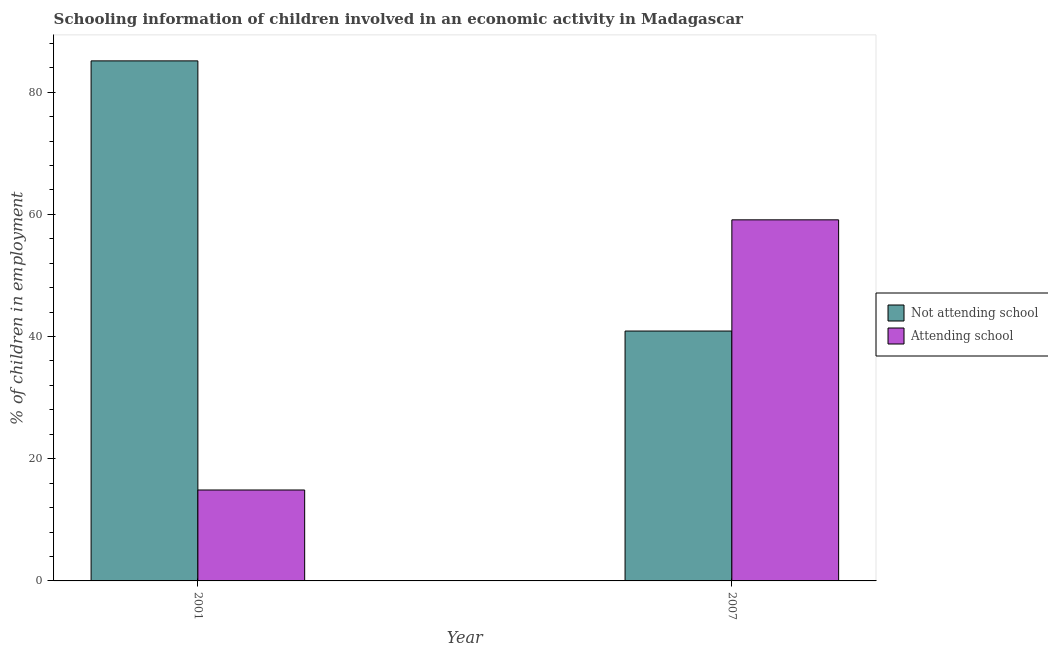How many different coloured bars are there?
Give a very brief answer. 2. How many groups of bars are there?
Your answer should be very brief. 2. Are the number of bars per tick equal to the number of legend labels?
Make the answer very short. Yes. Are the number of bars on each tick of the X-axis equal?
Provide a succinct answer. Yes. How many bars are there on the 2nd tick from the right?
Offer a very short reply. 2. What is the label of the 1st group of bars from the left?
Your answer should be very brief. 2001. What is the percentage of employed children who are not attending school in 2001?
Your response must be concise. 85.12. Across all years, what is the maximum percentage of employed children who are not attending school?
Ensure brevity in your answer.  85.12. Across all years, what is the minimum percentage of employed children who are not attending school?
Ensure brevity in your answer.  40.9. In which year was the percentage of employed children who are not attending school maximum?
Make the answer very short. 2001. In which year was the percentage of employed children who are attending school minimum?
Keep it short and to the point. 2001. What is the total percentage of employed children who are not attending school in the graph?
Ensure brevity in your answer.  126.02. What is the difference between the percentage of employed children who are not attending school in 2001 and that in 2007?
Provide a short and direct response. 44.22. What is the difference between the percentage of employed children who are attending school in 2001 and the percentage of employed children who are not attending school in 2007?
Ensure brevity in your answer.  -44.22. What is the average percentage of employed children who are attending school per year?
Give a very brief answer. 36.99. What is the ratio of the percentage of employed children who are attending school in 2001 to that in 2007?
Your response must be concise. 0.25. In how many years, is the percentage of employed children who are not attending school greater than the average percentage of employed children who are not attending school taken over all years?
Offer a very short reply. 1. What does the 2nd bar from the left in 2001 represents?
Provide a succinct answer. Attending school. What does the 1st bar from the right in 2001 represents?
Make the answer very short. Attending school. How many bars are there?
Make the answer very short. 4. Are the values on the major ticks of Y-axis written in scientific E-notation?
Your response must be concise. No. Does the graph contain grids?
Your answer should be compact. No. How many legend labels are there?
Your response must be concise. 2. What is the title of the graph?
Provide a succinct answer. Schooling information of children involved in an economic activity in Madagascar. What is the label or title of the Y-axis?
Your answer should be compact. % of children in employment. What is the % of children in employment in Not attending school in 2001?
Keep it short and to the point. 85.12. What is the % of children in employment in Attending school in 2001?
Provide a short and direct response. 14.88. What is the % of children in employment of Not attending school in 2007?
Provide a short and direct response. 40.9. What is the % of children in employment in Attending school in 2007?
Make the answer very short. 59.1. Across all years, what is the maximum % of children in employment in Not attending school?
Your response must be concise. 85.12. Across all years, what is the maximum % of children in employment in Attending school?
Offer a terse response. 59.1. Across all years, what is the minimum % of children in employment of Not attending school?
Offer a very short reply. 40.9. Across all years, what is the minimum % of children in employment in Attending school?
Your answer should be compact. 14.88. What is the total % of children in employment in Not attending school in the graph?
Provide a short and direct response. 126.02. What is the total % of children in employment of Attending school in the graph?
Your answer should be very brief. 73.98. What is the difference between the % of children in employment of Not attending school in 2001 and that in 2007?
Keep it short and to the point. 44.22. What is the difference between the % of children in employment of Attending school in 2001 and that in 2007?
Ensure brevity in your answer.  -44.22. What is the difference between the % of children in employment of Not attending school in 2001 and the % of children in employment of Attending school in 2007?
Your answer should be very brief. 26.02. What is the average % of children in employment of Not attending school per year?
Give a very brief answer. 63.01. What is the average % of children in employment of Attending school per year?
Ensure brevity in your answer.  36.99. In the year 2001, what is the difference between the % of children in employment of Not attending school and % of children in employment of Attending school?
Your answer should be very brief. 70.24. In the year 2007, what is the difference between the % of children in employment of Not attending school and % of children in employment of Attending school?
Ensure brevity in your answer.  -18.2. What is the ratio of the % of children in employment of Not attending school in 2001 to that in 2007?
Provide a short and direct response. 2.08. What is the ratio of the % of children in employment in Attending school in 2001 to that in 2007?
Provide a short and direct response. 0.25. What is the difference between the highest and the second highest % of children in employment in Not attending school?
Offer a terse response. 44.22. What is the difference between the highest and the second highest % of children in employment of Attending school?
Make the answer very short. 44.22. What is the difference between the highest and the lowest % of children in employment of Not attending school?
Keep it short and to the point. 44.22. What is the difference between the highest and the lowest % of children in employment of Attending school?
Give a very brief answer. 44.22. 